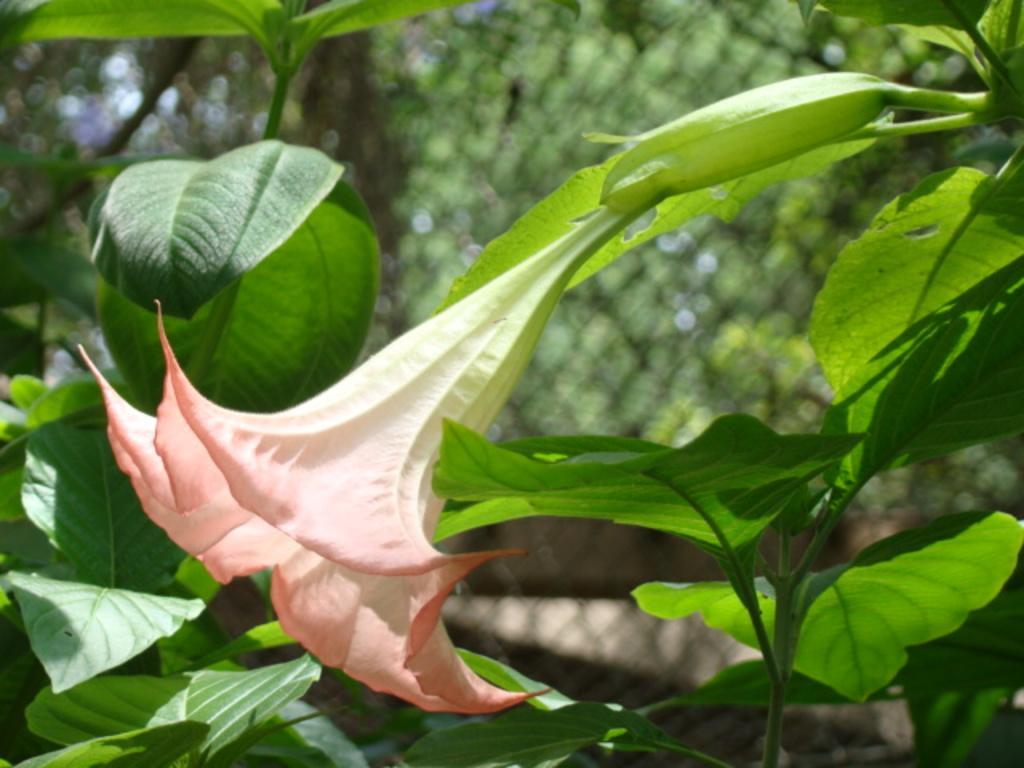Could you give a brief overview of what you see in this image? In this image we can see a flower with some plants and in the background, we can see some trees and a fence. 